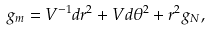<formula> <loc_0><loc_0><loc_500><loc_500>g _ { m } = V ^ { - 1 } d r ^ { 2 } + V d \theta ^ { 2 } + r ^ { 2 } g _ { N } ,</formula> 